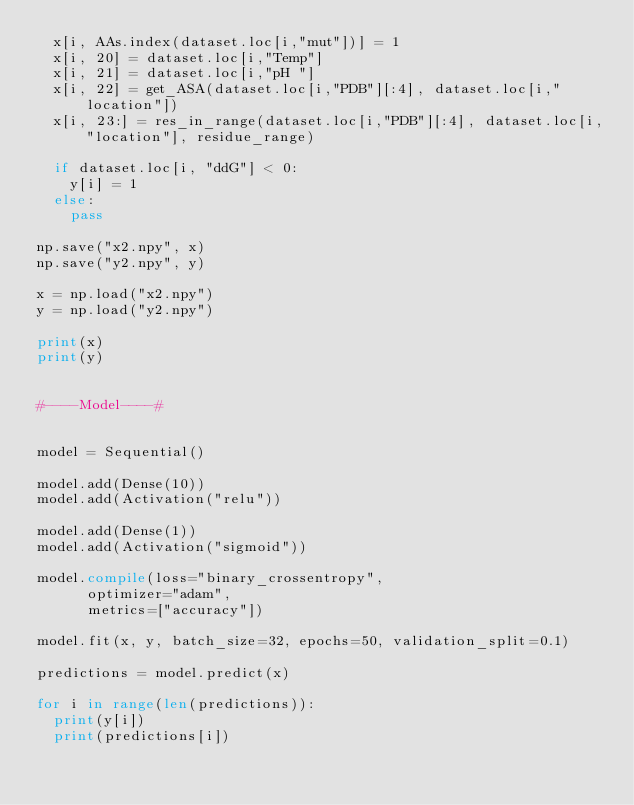Convert code to text. <code><loc_0><loc_0><loc_500><loc_500><_Python_>	x[i, AAs.index(dataset.loc[i,"mut"])] = 1
	x[i, 20] = dataset.loc[i,"Temp"]
	x[i, 21] = dataset.loc[i,"pH "]
	x[i, 22] = get_ASA(dataset.loc[i,"PDB"][:4], dataset.loc[i,"location"])
	x[i, 23:] = res_in_range(dataset.loc[i,"PDB"][:4], dataset.loc[i,"location"], residue_range)

	if dataset.loc[i, "ddG"] < 0:
		y[i] = 1
	else:
		pass

np.save("x2.npy", x)
np.save("y2.npy", y)

x = np.load("x2.npy")
y = np.load("y2.npy")

print(x)
print(y)


#----Model----#


model = Sequential()

model.add(Dense(10))
model.add(Activation("relu"))

model.add(Dense(1))
model.add(Activation("sigmoid"))

model.compile(loss="binary_crossentropy",
			optimizer="adam",
			metrics=["accuracy"])

model.fit(x, y, batch_size=32, epochs=50, validation_split=0.1)

predictions = model.predict(x)

for i in range(len(predictions)):
	print(y[i])
	print(predictions[i])
</code> 